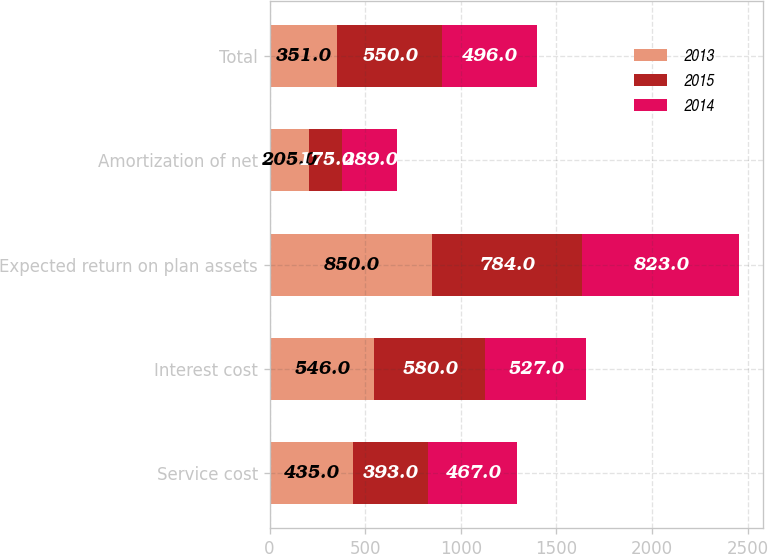<chart> <loc_0><loc_0><loc_500><loc_500><stacked_bar_chart><ecel><fcel>Service cost<fcel>Interest cost<fcel>Expected return on plan assets<fcel>Amortization of net<fcel>Total<nl><fcel>2013<fcel>435<fcel>546<fcel>850<fcel>205<fcel>351<nl><fcel>2015<fcel>393<fcel>580<fcel>784<fcel>175<fcel>550<nl><fcel>2014<fcel>467<fcel>527<fcel>823<fcel>289<fcel>496<nl></chart> 